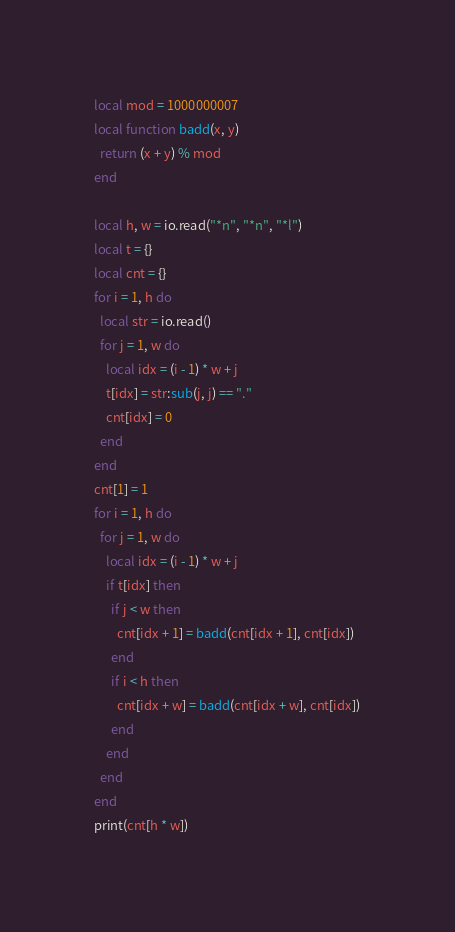Convert code to text. <code><loc_0><loc_0><loc_500><loc_500><_Lua_>local mod = 1000000007
local function badd(x, y)
  return (x + y) % mod
end

local h, w = io.read("*n", "*n", "*l")
local t = {}
local cnt = {}
for i = 1, h do
  local str = io.read()
  for j = 1, w do
    local idx = (i - 1) * w + j
    t[idx] = str:sub(j, j) == "."
    cnt[idx] = 0
  end
end
cnt[1] = 1
for i = 1, h do
  for j = 1, w do
    local idx = (i - 1) * w + j
    if t[idx] then
      if j < w then
        cnt[idx + 1] = badd(cnt[idx + 1], cnt[idx])
      end
      if i < h then
        cnt[idx + w] = badd(cnt[idx + w], cnt[idx])
      end
    end
  end
end
print(cnt[h * w])
</code> 